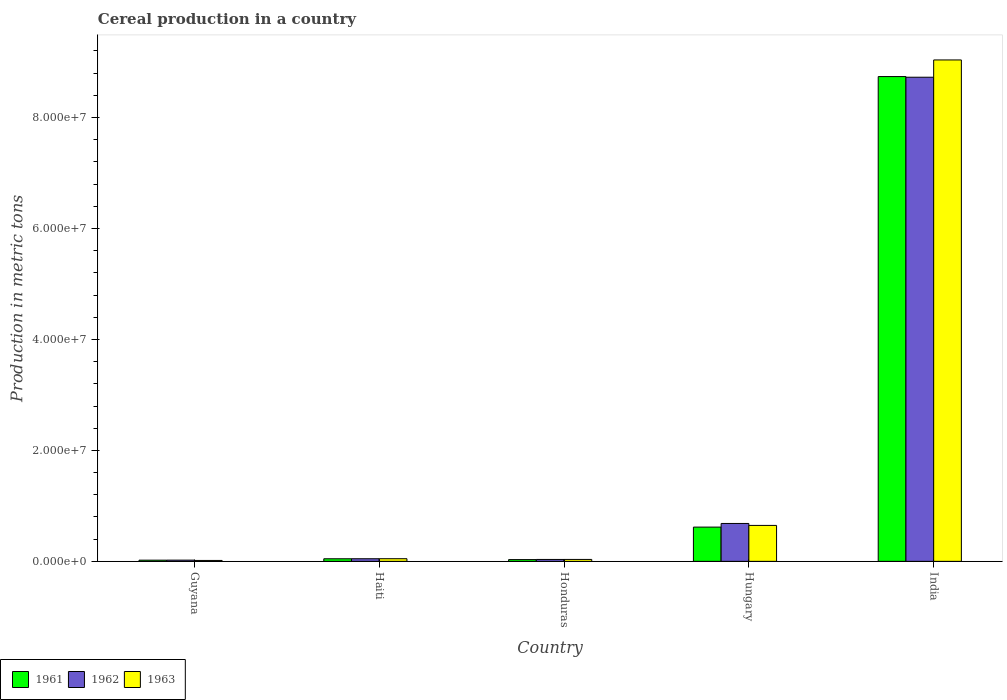How many groups of bars are there?
Your answer should be very brief. 5. Are the number of bars per tick equal to the number of legend labels?
Your answer should be very brief. Yes. Are the number of bars on each tick of the X-axis equal?
Give a very brief answer. Yes. How many bars are there on the 4th tick from the left?
Keep it short and to the point. 3. What is the label of the 3rd group of bars from the left?
Offer a very short reply. Honduras. What is the total cereal production in 1963 in Guyana?
Provide a short and direct response. 1.64e+05. Across all countries, what is the maximum total cereal production in 1963?
Provide a succinct answer. 9.04e+07. Across all countries, what is the minimum total cereal production in 1963?
Offer a terse response. 1.64e+05. In which country was the total cereal production in 1963 maximum?
Offer a terse response. India. In which country was the total cereal production in 1962 minimum?
Keep it short and to the point. Guyana. What is the total total cereal production in 1962 in the graph?
Provide a short and direct response. 9.51e+07. What is the difference between the total cereal production in 1961 in Hungary and that in India?
Make the answer very short. -8.12e+07. What is the difference between the total cereal production in 1963 in Honduras and the total cereal production in 1961 in Guyana?
Provide a succinct answer. 1.31e+05. What is the average total cereal production in 1963 per country?
Keep it short and to the point. 1.96e+07. What is the difference between the total cereal production of/in 1962 and total cereal production of/in 1961 in India?
Your answer should be very brief. -1.19e+05. What is the ratio of the total cereal production in 1963 in Haiti to that in Honduras?
Offer a terse response. 1.38. Is the total cereal production in 1961 in Honduras less than that in Hungary?
Provide a succinct answer. Yes. Is the difference between the total cereal production in 1962 in Guyana and Honduras greater than the difference between the total cereal production in 1961 in Guyana and Honduras?
Provide a succinct answer. No. What is the difference between the highest and the second highest total cereal production in 1962?
Ensure brevity in your answer.  8.04e+07. What is the difference between the highest and the lowest total cereal production in 1961?
Offer a very short reply. 8.72e+07. What does the 1st bar from the right in Honduras represents?
Your answer should be very brief. 1963. Does the graph contain grids?
Offer a very short reply. No. How are the legend labels stacked?
Offer a very short reply. Horizontal. What is the title of the graph?
Your answer should be compact. Cereal production in a country. Does "1964" appear as one of the legend labels in the graph?
Ensure brevity in your answer.  No. What is the label or title of the Y-axis?
Keep it short and to the point. Production in metric tons. What is the Production in metric tons of 1961 in Guyana?
Keep it short and to the point. 2.16e+05. What is the Production in metric tons in 1962 in Guyana?
Provide a short and direct response. 2.22e+05. What is the Production in metric tons of 1963 in Guyana?
Offer a terse response. 1.64e+05. What is the Production in metric tons of 1961 in Haiti?
Give a very brief answer. 4.66e+05. What is the Production in metric tons of 1962 in Haiti?
Your answer should be very brief. 4.72e+05. What is the Production in metric tons in 1963 in Haiti?
Ensure brevity in your answer.  4.78e+05. What is the Production in metric tons in 1961 in Honduras?
Provide a short and direct response. 3.18e+05. What is the Production in metric tons in 1962 in Honduras?
Ensure brevity in your answer.  3.44e+05. What is the Production in metric tons in 1963 in Honduras?
Your response must be concise. 3.47e+05. What is the Production in metric tons in 1961 in Hungary?
Offer a terse response. 6.17e+06. What is the Production in metric tons of 1962 in Hungary?
Ensure brevity in your answer.  6.83e+06. What is the Production in metric tons in 1963 in Hungary?
Offer a terse response. 6.48e+06. What is the Production in metric tons in 1961 in India?
Your answer should be very brief. 8.74e+07. What is the Production in metric tons in 1962 in India?
Give a very brief answer. 8.73e+07. What is the Production in metric tons in 1963 in India?
Ensure brevity in your answer.  9.04e+07. Across all countries, what is the maximum Production in metric tons in 1961?
Provide a succinct answer. 8.74e+07. Across all countries, what is the maximum Production in metric tons in 1962?
Make the answer very short. 8.73e+07. Across all countries, what is the maximum Production in metric tons in 1963?
Offer a very short reply. 9.04e+07. Across all countries, what is the minimum Production in metric tons of 1961?
Offer a very short reply. 2.16e+05. Across all countries, what is the minimum Production in metric tons in 1962?
Make the answer very short. 2.22e+05. Across all countries, what is the minimum Production in metric tons in 1963?
Provide a succinct answer. 1.64e+05. What is the total Production in metric tons in 1961 in the graph?
Make the answer very short. 9.46e+07. What is the total Production in metric tons in 1962 in the graph?
Make the answer very short. 9.51e+07. What is the total Production in metric tons in 1963 in the graph?
Offer a terse response. 9.78e+07. What is the difference between the Production in metric tons in 1961 in Guyana and that in Haiti?
Your answer should be very brief. -2.50e+05. What is the difference between the Production in metric tons of 1962 in Guyana and that in Haiti?
Make the answer very short. -2.51e+05. What is the difference between the Production in metric tons of 1963 in Guyana and that in Haiti?
Ensure brevity in your answer.  -3.14e+05. What is the difference between the Production in metric tons in 1961 in Guyana and that in Honduras?
Keep it short and to the point. -1.02e+05. What is the difference between the Production in metric tons in 1962 in Guyana and that in Honduras?
Provide a succinct answer. -1.22e+05. What is the difference between the Production in metric tons in 1963 in Guyana and that in Honduras?
Give a very brief answer. -1.83e+05. What is the difference between the Production in metric tons of 1961 in Guyana and that in Hungary?
Your answer should be compact. -5.96e+06. What is the difference between the Production in metric tons of 1962 in Guyana and that in Hungary?
Your response must be concise. -6.61e+06. What is the difference between the Production in metric tons in 1963 in Guyana and that in Hungary?
Make the answer very short. -6.31e+06. What is the difference between the Production in metric tons in 1961 in Guyana and that in India?
Your answer should be compact. -8.72e+07. What is the difference between the Production in metric tons in 1962 in Guyana and that in India?
Offer a terse response. -8.70e+07. What is the difference between the Production in metric tons in 1963 in Guyana and that in India?
Make the answer very short. -9.02e+07. What is the difference between the Production in metric tons of 1961 in Haiti and that in Honduras?
Give a very brief answer. 1.48e+05. What is the difference between the Production in metric tons of 1962 in Haiti and that in Honduras?
Keep it short and to the point. 1.29e+05. What is the difference between the Production in metric tons in 1963 in Haiti and that in Honduras?
Your answer should be compact. 1.31e+05. What is the difference between the Production in metric tons of 1961 in Haiti and that in Hungary?
Your answer should be compact. -5.71e+06. What is the difference between the Production in metric tons of 1962 in Haiti and that in Hungary?
Your answer should be compact. -6.36e+06. What is the difference between the Production in metric tons of 1963 in Haiti and that in Hungary?
Make the answer very short. -6.00e+06. What is the difference between the Production in metric tons in 1961 in Haiti and that in India?
Your answer should be compact. -8.69e+07. What is the difference between the Production in metric tons in 1962 in Haiti and that in India?
Offer a terse response. -8.68e+07. What is the difference between the Production in metric tons of 1963 in Haiti and that in India?
Offer a very short reply. -8.99e+07. What is the difference between the Production in metric tons in 1961 in Honduras and that in Hungary?
Make the answer very short. -5.86e+06. What is the difference between the Production in metric tons in 1962 in Honduras and that in Hungary?
Provide a succinct answer. -6.49e+06. What is the difference between the Production in metric tons of 1963 in Honduras and that in Hungary?
Keep it short and to the point. -6.13e+06. What is the difference between the Production in metric tons of 1961 in Honduras and that in India?
Your answer should be very brief. -8.71e+07. What is the difference between the Production in metric tons in 1962 in Honduras and that in India?
Offer a very short reply. -8.69e+07. What is the difference between the Production in metric tons of 1963 in Honduras and that in India?
Give a very brief answer. -9.00e+07. What is the difference between the Production in metric tons in 1961 in Hungary and that in India?
Keep it short and to the point. -8.12e+07. What is the difference between the Production in metric tons in 1962 in Hungary and that in India?
Offer a terse response. -8.04e+07. What is the difference between the Production in metric tons of 1963 in Hungary and that in India?
Give a very brief answer. -8.39e+07. What is the difference between the Production in metric tons of 1961 in Guyana and the Production in metric tons of 1962 in Haiti?
Give a very brief answer. -2.56e+05. What is the difference between the Production in metric tons in 1961 in Guyana and the Production in metric tons in 1963 in Haiti?
Provide a short and direct response. -2.62e+05. What is the difference between the Production in metric tons in 1962 in Guyana and the Production in metric tons in 1963 in Haiti?
Your answer should be compact. -2.56e+05. What is the difference between the Production in metric tons in 1961 in Guyana and the Production in metric tons in 1962 in Honduras?
Your answer should be very brief. -1.27e+05. What is the difference between the Production in metric tons of 1961 in Guyana and the Production in metric tons of 1963 in Honduras?
Your response must be concise. -1.31e+05. What is the difference between the Production in metric tons of 1962 in Guyana and the Production in metric tons of 1963 in Honduras?
Offer a terse response. -1.25e+05. What is the difference between the Production in metric tons in 1961 in Guyana and the Production in metric tons in 1962 in Hungary?
Give a very brief answer. -6.61e+06. What is the difference between the Production in metric tons of 1961 in Guyana and the Production in metric tons of 1963 in Hungary?
Your answer should be compact. -6.26e+06. What is the difference between the Production in metric tons in 1962 in Guyana and the Production in metric tons in 1963 in Hungary?
Your answer should be very brief. -6.26e+06. What is the difference between the Production in metric tons of 1961 in Guyana and the Production in metric tons of 1962 in India?
Keep it short and to the point. -8.70e+07. What is the difference between the Production in metric tons of 1961 in Guyana and the Production in metric tons of 1963 in India?
Provide a short and direct response. -9.02e+07. What is the difference between the Production in metric tons in 1962 in Guyana and the Production in metric tons in 1963 in India?
Your response must be concise. -9.02e+07. What is the difference between the Production in metric tons of 1961 in Haiti and the Production in metric tons of 1962 in Honduras?
Make the answer very short. 1.22e+05. What is the difference between the Production in metric tons of 1961 in Haiti and the Production in metric tons of 1963 in Honduras?
Give a very brief answer. 1.19e+05. What is the difference between the Production in metric tons of 1962 in Haiti and the Production in metric tons of 1963 in Honduras?
Ensure brevity in your answer.  1.25e+05. What is the difference between the Production in metric tons in 1961 in Haiti and the Production in metric tons in 1962 in Hungary?
Keep it short and to the point. -6.36e+06. What is the difference between the Production in metric tons of 1961 in Haiti and the Production in metric tons of 1963 in Hungary?
Your answer should be very brief. -6.01e+06. What is the difference between the Production in metric tons of 1962 in Haiti and the Production in metric tons of 1963 in Hungary?
Make the answer very short. -6.01e+06. What is the difference between the Production in metric tons in 1961 in Haiti and the Production in metric tons in 1962 in India?
Give a very brief answer. -8.68e+07. What is the difference between the Production in metric tons of 1961 in Haiti and the Production in metric tons of 1963 in India?
Your answer should be very brief. -8.99e+07. What is the difference between the Production in metric tons in 1962 in Haiti and the Production in metric tons in 1963 in India?
Ensure brevity in your answer.  -8.99e+07. What is the difference between the Production in metric tons in 1961 in Honduras and the Production in metric tons in 1962 in Hungary?
Offer a very short reply. -6.51e+06. What is the difference between the Production in metric tons in 1961 in Honduras and the Production in metric tons in 1963 in Hungary?
Give a very brief answer. -6.16e+06. What is the difference between the Production in metric tons in 1962 in Honduras and the Production in metric tons in 1963 in Hungary?
Make the answer very short. -6.14e+06. What is the difference between the Production in metric tons in 1961 in Honduras and the Production in metric tons in 1962 in India?
Provide a succinct answer. -8.69e+07. What is the difference between the Production in metric tons in 1961 in Honduras and the Production in metric tons in 1963 in India?
Your response must be concise. -9.01e+07. What is the difference between the Production in metric tons in 1962 in Honduras and the Production in metric tons in 1963 in India?
Offer a terse response. -9.00e+07. What is the difference between the Production in metric tons of 1961 in Hungary and the Production in metric tons of 1962 in India?
Provide a succinct answer. -8.11e+07. What is the difference between the Production in metric tons in 1961 in Hungary and the Production in metric tons in 1963 in India?
Keep it short and to the point. -8.42e+07. What is the difference between the Production in metric tons of 1962 in Hungary and the Production in metric tons of 1963 in India?
Your answer should be compact. -8.35e+07. What is the average Production in metric tons in 1961 per country?
Your answer should be compact. 1.89e+07. What is the average Production in metric tons of 1962 per country?
Provide a short and direct response. 1.90e+07. What is the average Production in metric tons in 1963 per country?
Your response must be concise. 1.96e+07. What is the difference between the Production in metric tons of 1961 and Production in metric tons of 1962 in Guyana?
Ensure brevity in your answer.  -5445. What is the difference between the Production in metric tons in 1961 and Production in metric tons in 1963 in Guyana?
Offer a terse response. 5.19e+04. What is the difference between the Production in metric tons of 1962 and Production in metric tons of 1963 in Guyana?
Offer a terse response. 5.74e+04. What is the difference between the Production in metric tons of 1961 and Production in metric tons of 1962 in Haiti?
Your answer should be compact. -6500. What is the difference between the Production in metric tons of 1961 and Production in metric tons of 1963 in Haiti?
Your answer should be compact. -1.20e+04. What is the difference between the Production in metric tons of 1962 and Production in metric tons of 1963 in Haiti?
Offer a terse response. -5500. What is the difference between the Production in metric tons of 1961 and Production in metric tons of 1962 in Honduras?
Make the answer very short. -2.57e+04. What is the difference between the Production in metric tons of 1961 and Production in metric tons of 1963 in Honduras?
Provide a succinct answer. -2.92e+04. What is the difference between the Production in metric tons in 1962 and Production in metric tons in 1963 in Honduras?
Your response must be concise. -3541. What is the difference between the Production in metric tons in 1961 and Production in metric tons in 1962 in Hungary?
Your response must be concise. -6.55e+05. What is the difference between the Production in metric tons in 1961 and Production in metric tons in 1963 in Hungary?
Offer a terse response. -3.04e+05. What is the difference between the Production in metric tons in 1962 and Production in metric tons in 1963 in Hungary?
Your answer should be compact. 3.51e+05. What is the difference between the Production in metric tons of 1961 and Production in metric tons of 1962 in India?
Offer a very short reply. 1.19e+05. What is the difference between the Production in metric tons of 1961 and Production in metric tons of 1963 in India?
Your answer should be compact. -3.00e+06. What is the difference between the Production in metric tons of 1962 and Production in metric tons of 1963 in India?
Your answer should be very brief. -3.12e+06. What is the ratio of the Production in metric tons of 1961 in Guyana to that in Haiti?
Make the answer very short. 0.46. What is the ratio of the Production in metric tons of 1962 in Guyana to that in Haiti?
Ensure brevity in your answer.  0.47. What is the ratio of the Production in metric tons of 1963 in Guyana to that in Haiti?
Make the answer very short. 0.34. What is the ratio of the Production in metric tons of 1961 in Guyana to that in Honduras?
Offer a terse response. 0.68. What is the ratio of the Production in metric tons of 1962 in Guyana to that in Honduras?
Give a very brief answer. 0.65. What is the ratio of the Production in metric tons in 1963 in Guyana to that in Honduras?
Offer a very short reply. 0.47. What is the ratio of the Production in metric tons in 1961 in Guyana to that in Hungary?
Provide a short and direct response. 0.04. What is the ratio of the Production in metric tons in 1962 in Guyana to that in Hungary?
Give a very brief answer. 0.03. What is the ratio of the Production in metric tons in 1963 in Guyana to that in Hungary?
Offer a very short reply. 0.03. What is the ratio of the Production in metric tons of 1961 in Guyana to that in India?
Your response must be concise. 0. What is the ratio of the Production in metric tons of 1962 in Guyana to that in India?
Keep it short and to the point. 0. What is the ratio of the Production in metric tons in 1963 in Guyana to that in India?
Your answer should be compact. 0. What is the ratio of the Production in metric tons of 1961 in Haiti to that in Honduras?
Your response must be concise. 1.47. What is the ratio of the Production in metric tons of 1962 in Haiti to that in Honduras?
Make the answer very short. 1.37. What is the ratio of the Production in metric tons in 1963 in Haiti to that in Honduras?
Ensure brevity in your answer.  1.38. What is the ratio of the Production in metric tons in 1961 in Haiti to that in Hungary?
Ensure brevity in your answer.  0.08. What is the ratio of the Production in metric tons in 1962 in Haiti to that in Hungary?
Your answer should be compact. 0.07. What is the ratio of the Production in metric tons in 1963 in Haiti to that in Hungary?
Give a very brief answer. 0.07. What is the ratio of the Production in metric tons in 1961 in Haiti to that in India?
Keep it short and to the point. 0.01. What is the ratio of the Production in metric tons in 1962 in Haiti to that in India?
Your answer should be very brief. 0.01. What is the ratio of the Production in metric tons of 1963 in Haiti to that in India?
Offer a terse response. 0.01. What is the ratio of the Production in metric tons of 1961 in Honduras to that in Hungary?
Your answer should be very brief. 0.05. What is the ratio of the Production in metric tons in 1962 in Honduras to that in Hungary?
Offer a terse response. 0.05. What is the ratio of the Production in metric tons in 1963 in Honduras to that in Hungary?
Your answer should be very brief. 0.05. What is the ratio of the Production in metric tons of 1961 in Honduras to that in India?
Ensure brevity in your answer.  0. What is the ratio of the Production in metric tons in 1962 in Honduras to that in India?
Make the answer very short. 0. What is the ratio of the Production in metric tons in 1963 in Honduras to that in India?
Offer a terse response. 0. What is the ratio of the Production in metric tons of 1961 in Hungary to that in India?
Your response must be concise. 0.07. What is the ratio of the Production in metric tons of 1962 in Hungary to that in India?
Your answer should be compact. 0.08. What is the ratio of the Production in metric tons in 1963 in Hungary to that in India?
Offer a very short reply. 0.07. What is the difference between the highest and the second highest Production in metric tons in 1961?
Keep it short and to the point. 8.12e+07. What is the difference between the highest and the second highest Production in metric tons in 1962?
Make the answer very short. 8.04e+07. What is the difference between the highest and the second highest Production in metric tons of 1963?
Keep it short and to the point. 8.39e+07. What is the difference between the highest and the lowest Production in metric tons of 1961?
Your answer should be very brief. 8.72e+07. What is the difference between the highest and the lowest Production in metric tons of 1962?
Your response must be concise. 8.70e+07. What is the difference between the highest and the lowest Production in metric tons of 1963?
Give a very brief answer. 9.02e+07. 